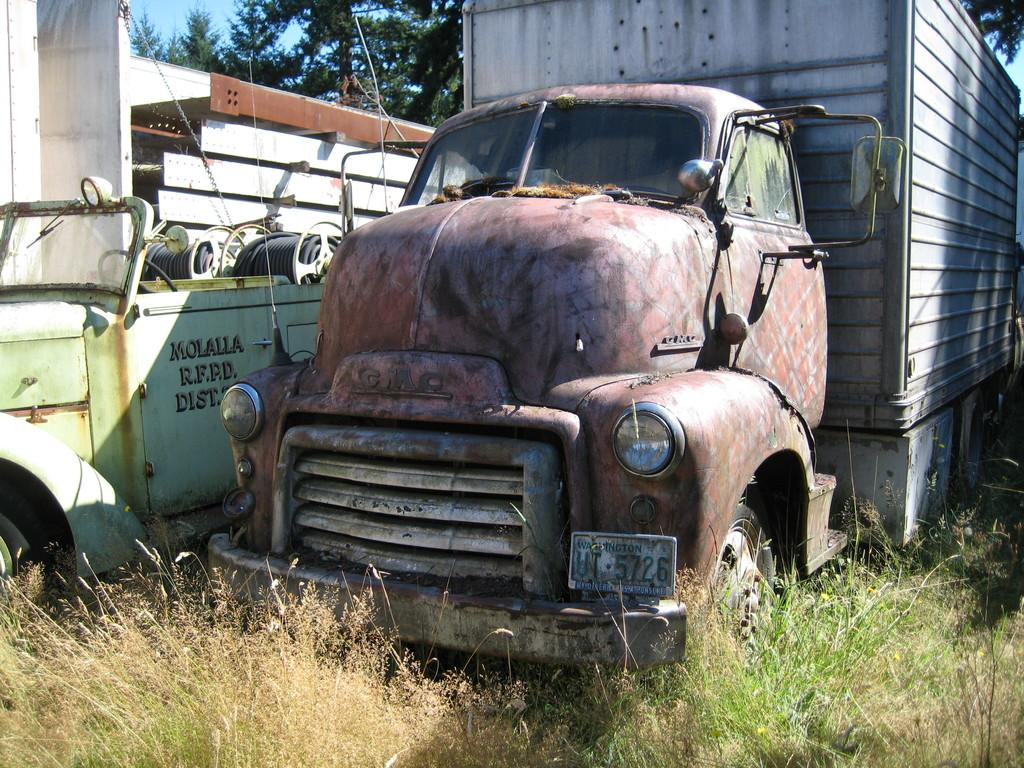What type of vehicle is on the ground in the image? There is a truck on the ground in the image. What feature can be seen on the truck? The truck has headlights. What type of terrain is visible in the image? There is grass visible in the image. Can you describe the setting of the image? There is a vehicle, trees, and the sky visible in the image. What type of invention is being demonstrated in the image? There is no invention being demonstrated in the image; it features a truck on the ground with grass, trees, and the sky visible. What type of machine is being used to harvest the crops in the image? There are no crops or machines related to crop harvesting present in the image. 